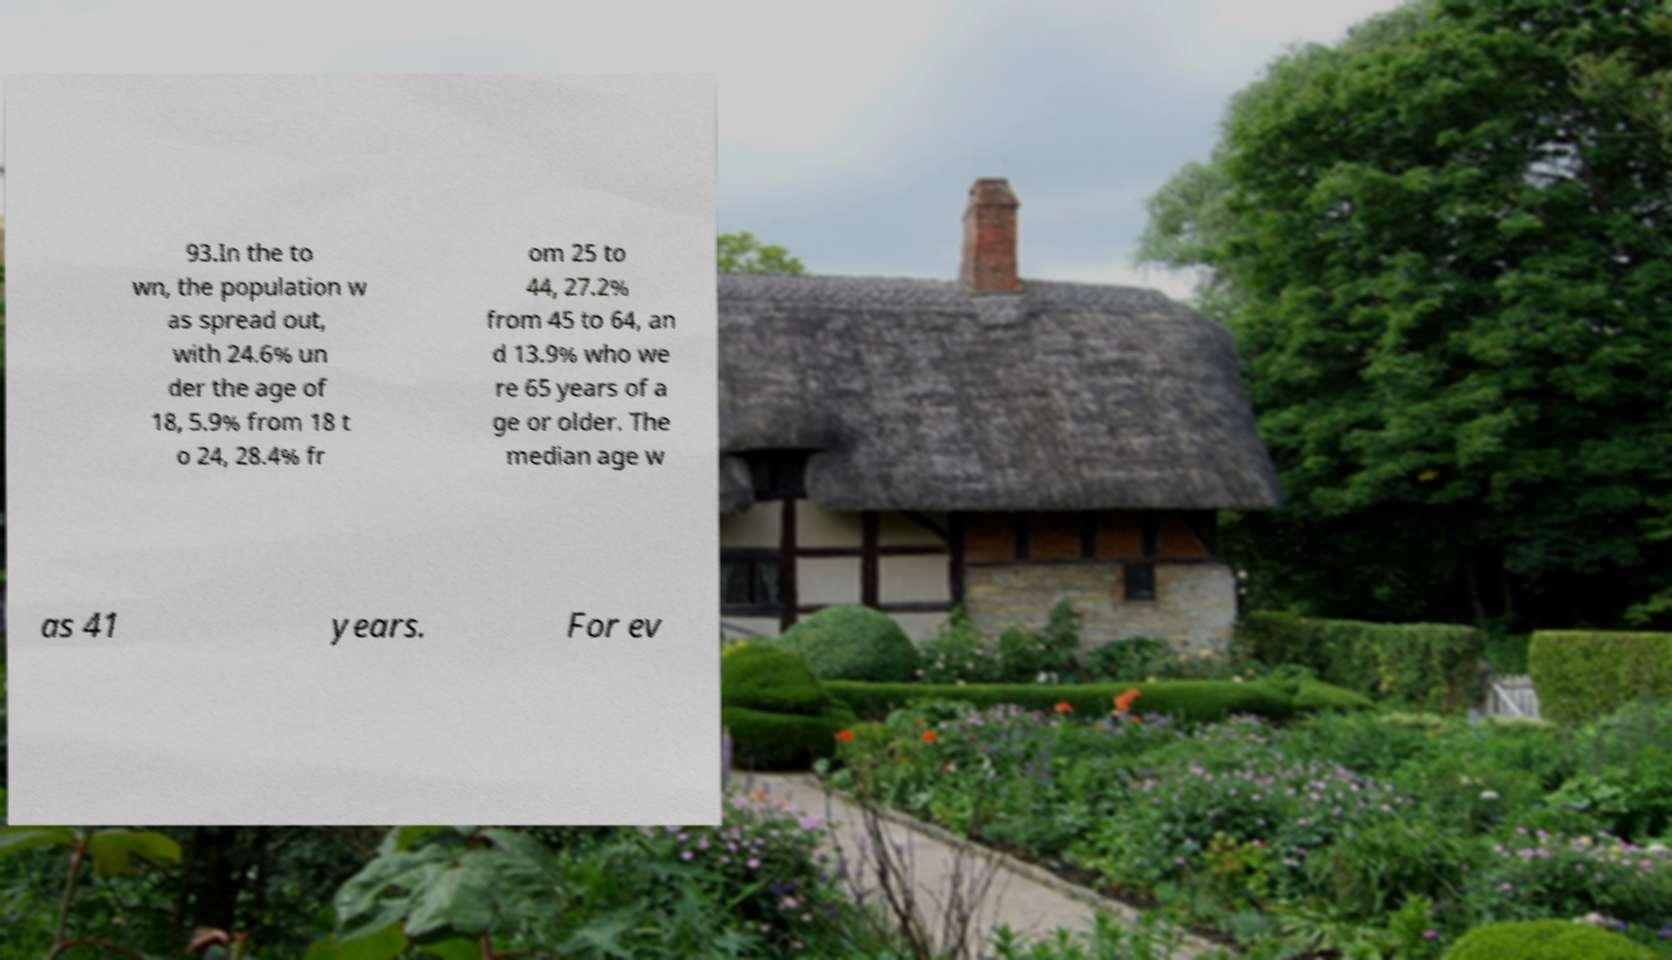Please read and relay the text visible in this image. What does it say? 93.In the to wn, the population w as spread out, with 24.6% un der the age of 18, 5.9% from 18 t o 24, 28.4% fr om 25 to 44, 27.2% from 45 to 64, an d 13.9% who we re 65 years of a ge or older. The median age w as 41 years. For ev 